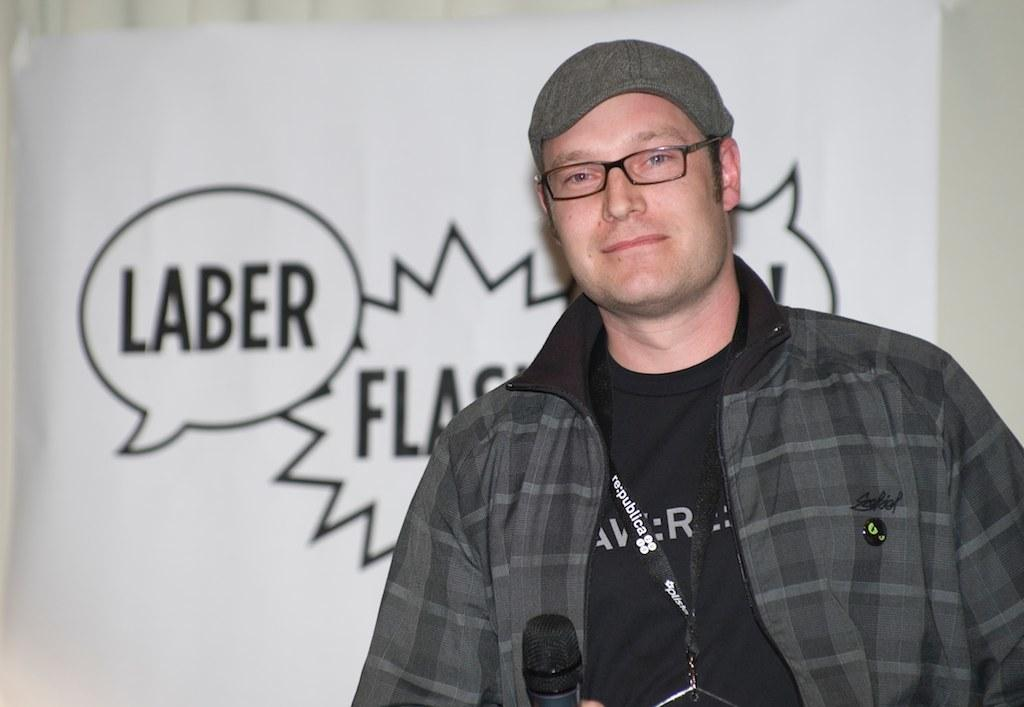What is the man in the image doing? The man is standing in the image and holding a microphone. What might the man be using the microphone for? The man might be using the microphone for speaking or singing. Can you describe anything in the background of the image? Yes, there is a paper with words and symbols in the background of the image. What type of mine is visible in the image? There is no mine present in the image; it features a man holding a microphone and a paper with words and symbols in the background. 